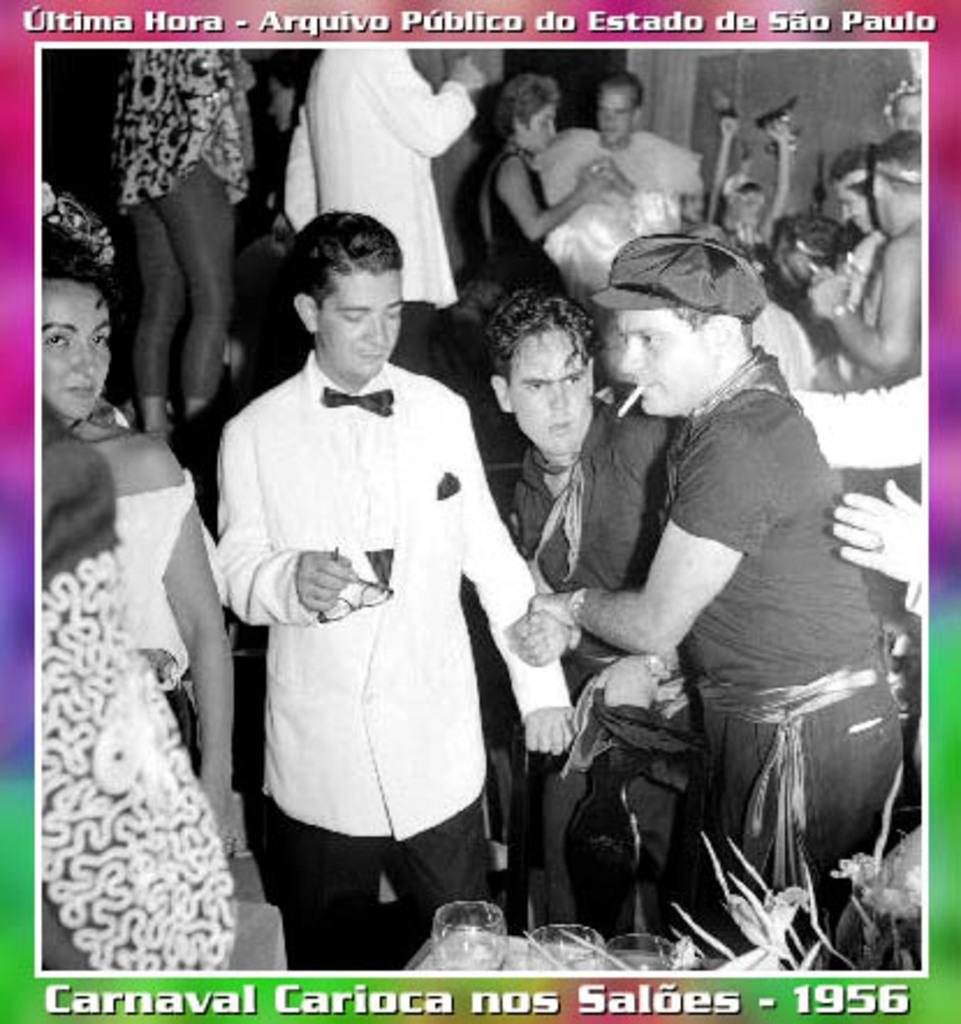What is the main subject of the image? The main subject of the image is a photograph. What can be seen in the center of the photograph? There are people in the center of the photograph. What objects are located at the bottom side of the photograph? There are glasses at the bottom side of the photograph. What type of cast can be seen on the person's arm in the image? There is no cast visible on anyone's arm in the image; it only features a photograph with people and glasses. 